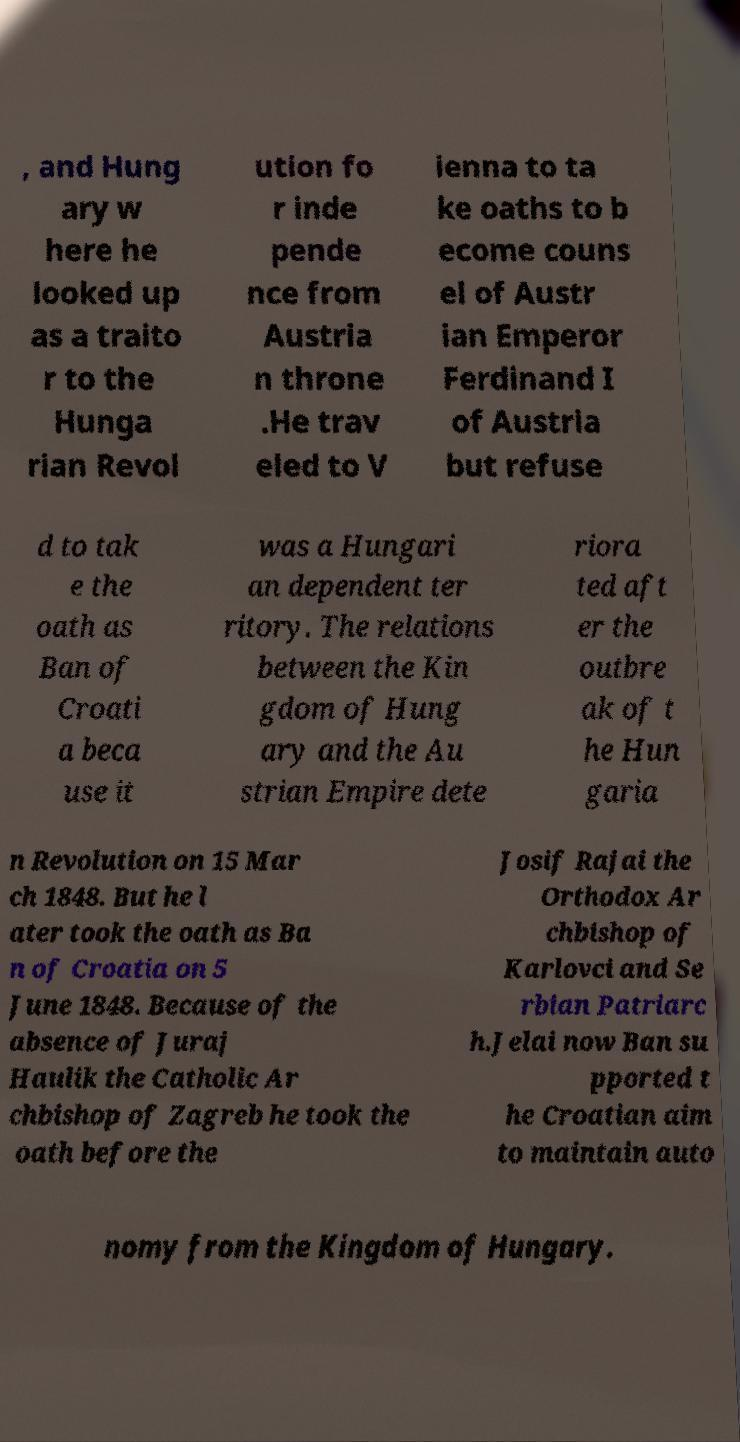There's text embedded in this image that I need extracted. Can you transcribe it verbatim? , and Hung ary w here he looked up as a traito r to the Hunga rian Revol ution fo r inde pende nce from Austria n throne .He trav eled to V ienna to ta ke oaths to b ecome couns el of Austr ian Emperor Ferdinand I of Austria but refuse d to tak e the oath as Ban of Croati a beca use it was a Hungari an dependent ter ritory. The relations between the Kin gdom of Hung ary and the Au strian Empire dete riora ted aft er the outbre ak of t he Hun garia n Revolution on 15 Mar ch 1848. But he l ater took the oath as Ba n of Croatia on 5 June 1848. Because of the absence of Juraj Haulik the Catholic Ar chbishop of Zagreb he took the oath before the Josif Rajai the Orthodox Ar chbishop of Karlovci and Se rbian Patriarc h.Jelai now Ban su pported t he Croatian aim to maintain auto nomy from the Kingdom of Hungary. 